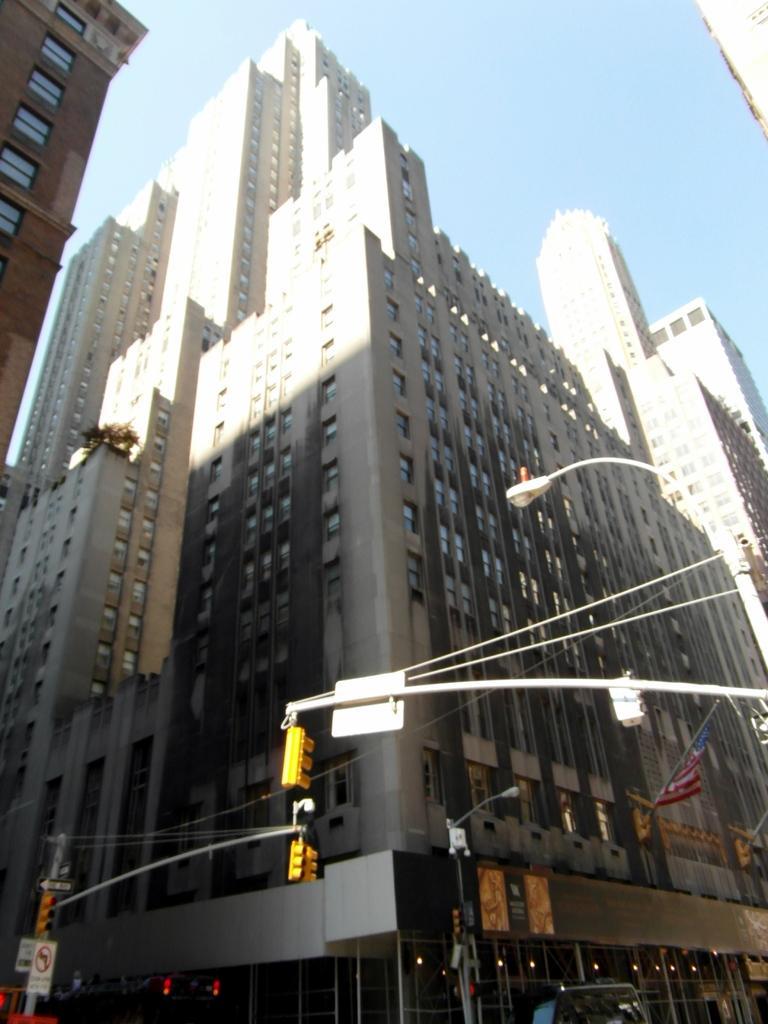In one or two sentences, can you explain what this image depicts? In this image there are buildings, poles, signals, streetlights and the sky. 